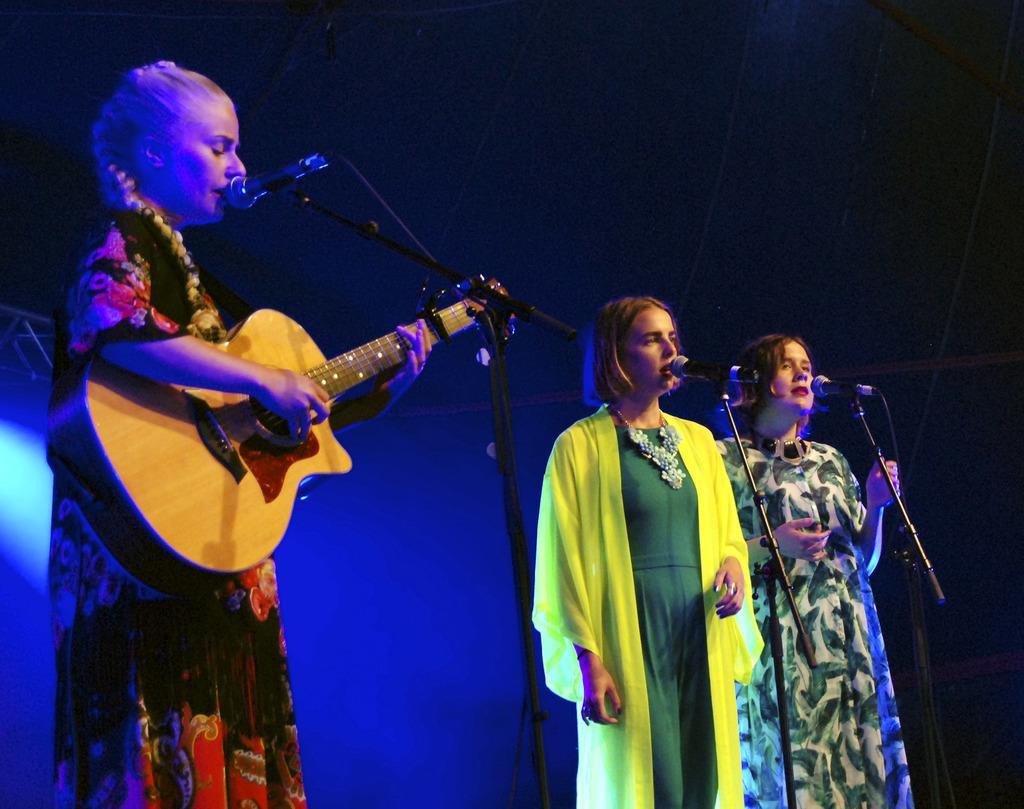Could you give a brief overview of what you see in this image? In this image there are three women standing there is a microphone in front a woman and holding a guitar in her hand, at the back ground i can see a light. 